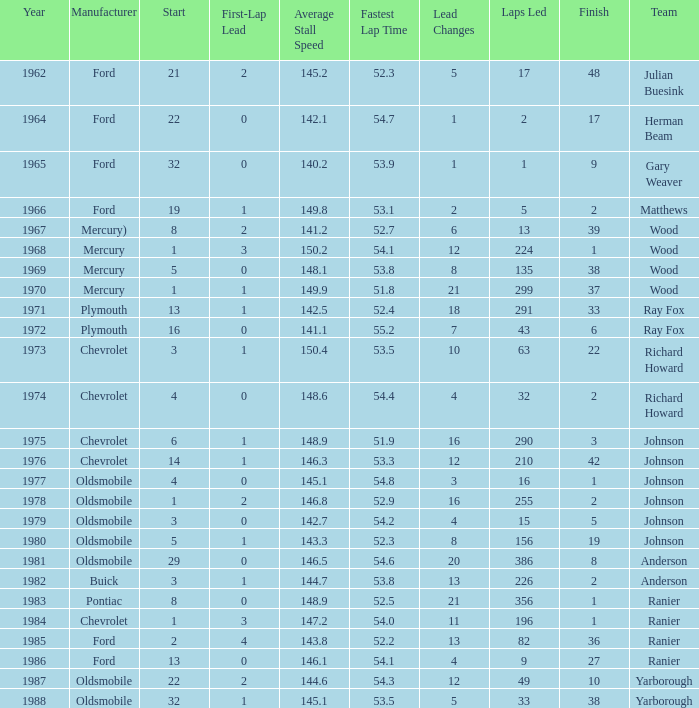What is the smallest finish time for a race after 1972 with a car manufactured by pontiac? 1.0. Can you parse all the data within this table? {'header': ['Year', 'Manufacturer', 'Start', 'First-Lap Lead', 'Average Stall Speed', 'Fastest Lap Time', 'Lead Changes', 'Laps Led', 'Finish', 'Team'], 'rows': [['1962', 'Ford', '21', '2', '145.2', '52.3', '5', '17', '48', 'Julian Buesink'], ['1964', 'Ford', '22', '0', '142.1', '54.7', '1', '2', '17', 'Herman Beam'], ['1965', 'Ford', '32', '0', '140.2', '53.9', '1', '1', '9', 'Gary Weaver'], ['1966', 'Ford', '19', '1', '149.8', '53.1', '2', '5', '2', 'Matthews'], ['1967', 'Mercury)', '8', '2', '141.2', '52.7', '6', '13', '39', 'Wood'], ['1968', 'Mercury', '1', '3', '150.2', '54.1', '12', '224', '1', 'Wood'], ['1969', 'Mercury', '5', '0', '148.1', '53.8', '8', '135', '38', 'Wood'], ['1970', 'Mercury', '1', '1', '149.9', '51.8', '21', '299', '37', 'Wood'], ['1971', 'Plymouth', '13', '1', '142.5', '52.4', '18', '291', '33', 'Ray Fox'], ['1972', 'Plymouth', '16', '0', '141.1', '55.2', '7', '43', '6', 'Ray Fox'], ['1973', 'Chevrolet', '3', '1', '150.4', '53.5', '10', '63', '22', 'Richard Howard'], ['1974', 'Chevrolet', '4', '0', '148.6', '54.4', '4', '32', '2', 'Richard Howard'], ['1975', 'Chevrolet', '6', '1', '148.9', '51.9', '16', '290', '3', 'Johnson'], ['1976', 'Chevrolet', '14', '1', '146.3', '53.3', '12', '210', '42', 'Johnson'], ['1977', 'Oldsmobile', '4', '0', '145.1', '54.8', '3', '16', '1', 'Johnson'], ['1978', 'Oldsmobile', '1', '2', '146.8', '52.9', '16', '255', '2', 'Johnson'], ['1979', 'Oldsmobile', '3', '0', '142.7', '54.2', '4', '15', '5', 'Johnson'], ['1980', 'Oldsmobile', '5', '1', '143.3', '52.3', '8', '156', '19', 'Johnson'], ['1981', 'Oldsmobile', '29', '0', '146.5', '54.6', '20', '386', '8', 'Anderson'], ['1982', 'Buick', '3', '1', '144.7', '53.8', '13', '226', '2', 'Anderson'], ['1983', 'Pontiac', '8', '0', '148.9', '52.5', '21', '356', '1', 'Ranier'], ['1984', 'Chevrolet', '1', '3', '147.2', '54.0', '11', '196', '1', 'Ranier'], ['1985', 'Ford', '2', '4', '143.8', '52.2', '13', '82', '36', 'Ranier'], ['1986', 'Ford', '13', '0', '146.1', '54.1', '4', '9', '27', 'Ranier'], ['1987', 'Oldsmobile', '22', '2', '144.6', '54.3', '12', '49', '10', 'Yarborough'], ['1988', 'Oldsmobile', '32', '1', '145.1', '53.5', '5', '33', '38', 'Yarborough']]} 